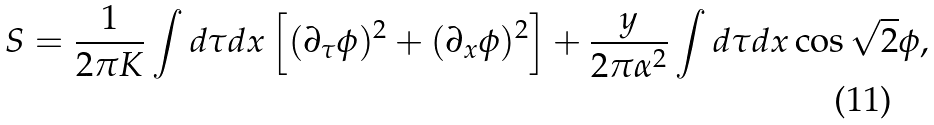Convert formula to latex. <formula><loc_0><loc_0><loc_500><loc_500>S = \frac { 1 } { 2 \pi K } \int d \tau d x \left [ ( \partial _ { \tau } \phi ) ^ { 2 } + ( \partial _ { x } \phi ) ^ { 2 } \right ] + \frac { y } { 2 \pi \alpha ^ { 2 } } \int d \tau d x \cos \sqrt { 2 } \phi ,</formula> 